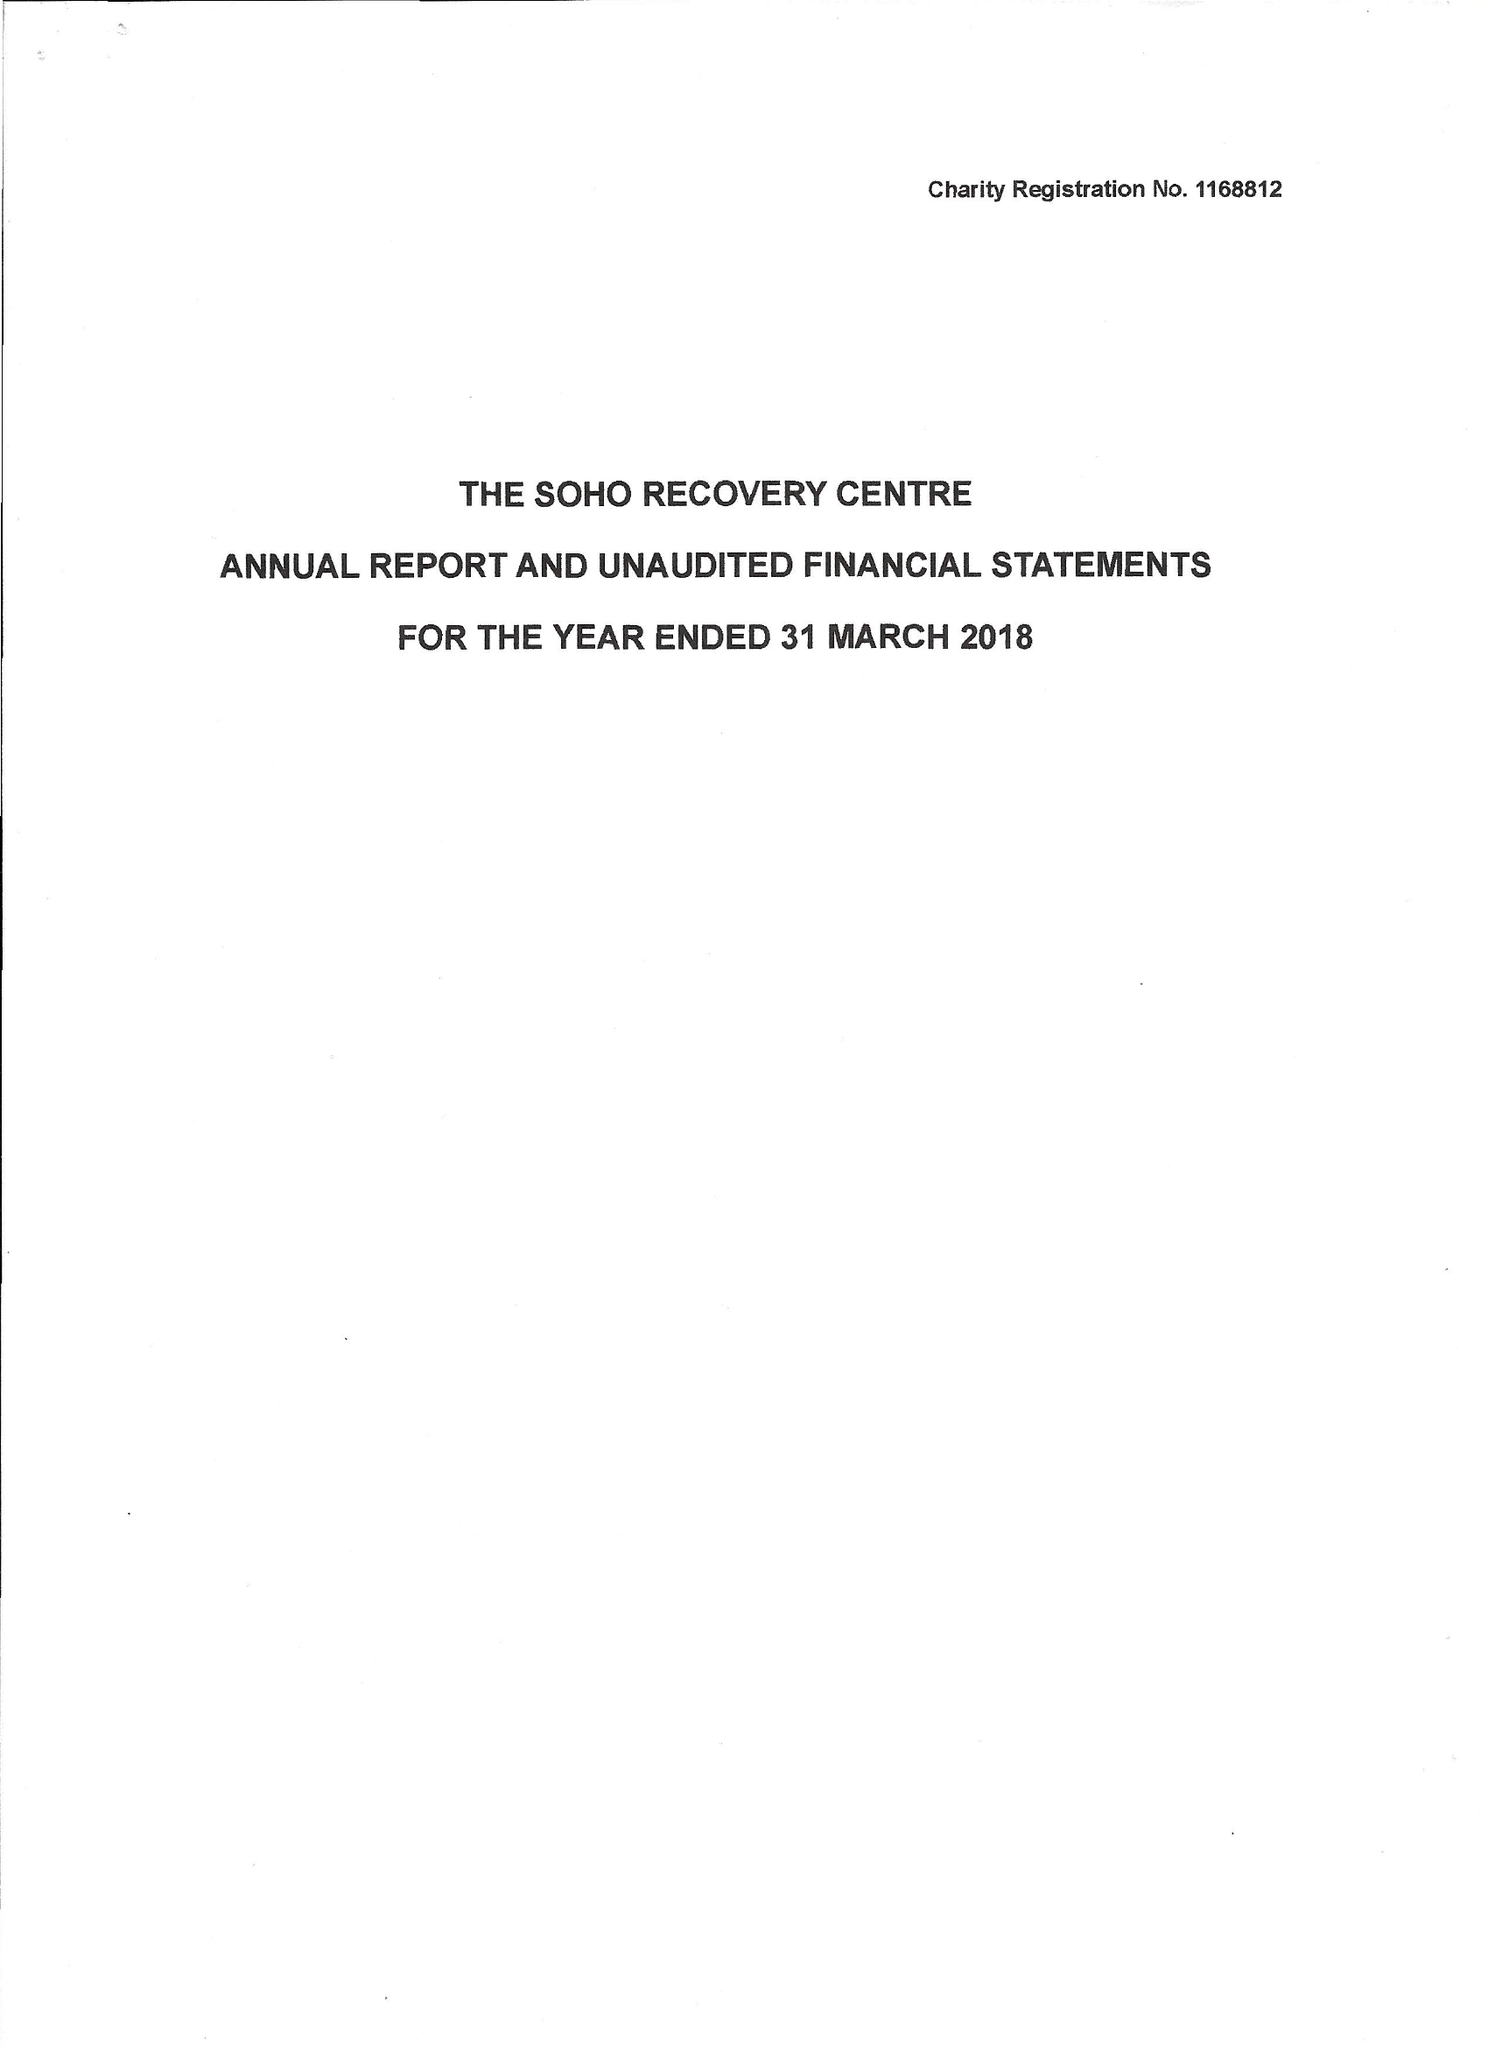What is the value for the address__street_line?
Answer the question using a single word or phrase. 123 CHARING CROSS ROAD 